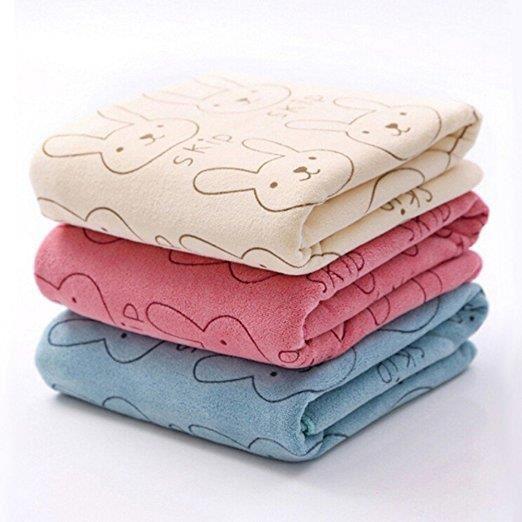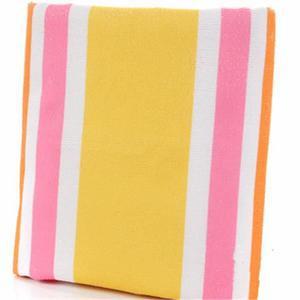The first image is the image on the left, the second image is the image on the right. For the images displayed, is the sentence "The towels on the right side image are rolled up." factually correct? Answer yes or no. No. The first image is the image on the left, the second image is the image on the right. Considering the images on both sides, is "Towels in one image, each of them a different color, are folded into neat stacked squares." valid? Answer yes or no. Yes. 